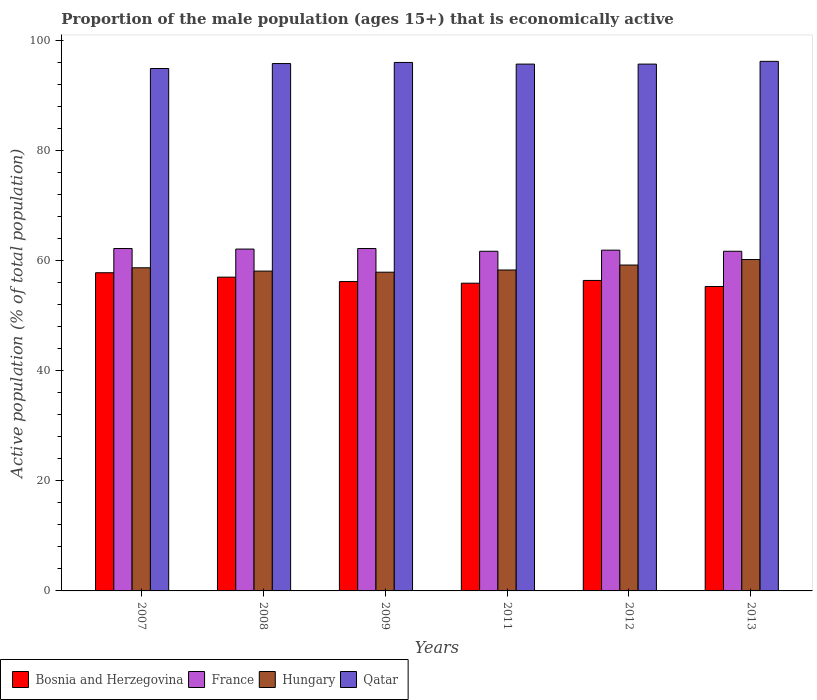How many different coloured bars are there?
Make the answer very short. 4. How many bars are there on the 4th tick from the right?
Give a very brief answer. 4. What is the label of the 5th group of bars from the left?
Your response must be concise. 2012. What is the proportion of the male population that is economically active in Hungary in 2008?
Your response must be concise. 58.1. Across all years, what is the maximum proportion of the male population that is economically active in France?
Keep it short and to the point. 62.2. Across all years, what is the minimum proportion of the male population that is economically active in Qatar?
Provide a short and direct response. 94.9. In which year was the proportion of the male population that is economically active in Bosnia and Herzegovina maximum?
Give a very brief answer. 2007. What is the total proportion of the male population that is economically active in Qatar in the graph?
Your response must be concise. 574.3. What is the difference between the proportion of the male population that is economically active in Hungary in 2009 and that in 2013?
Ensure brevity in your answer.  -2.3. What is the difference between the proportion of the male population that is economically active in Qatar in 2011 and the proportion of the male population that is economically active in Hungary in 2013?
Provide a succinct answer. 35.5. What is the average proportion of the male population that is economically active in Qatar per year?
Make the answer very short. 95.72. In the year 2011, what is the difference between the proportion of the male population that is economically active in Bosnia and Herzegovina and proportion of the male population that is economically active in France?
Your answer should be compact. -5.8. In how many years, is the proportion of the male population that is economically active in Hungary greater than 12 %?
Provide a succinct answer. 6. What is the ratio of the proportion of the male population that is economically active in Hungary in 2012 to that in 2013?
Give a very brief answer. 0.98. What is the difference between the highest and the second highest proportion of the male population that is economically active in Hungary?
Keep it short and to the point. 1. What is the difference between the highest and the lowest proportion of the male population that is economically active in France?
Ensure brevity in your answer.  0.5. In how many years, is the proportion of the male population that is economically active in Hungary greater than the average proportion of the male population that is economically active in Hungary taken over all years?
Provide a short and direct response. 2. What does the 3rd bar from the left in 2009 represents?
Keep it short and to the point. Hungary. What does the 4th bar from the right in 2009 represents?
Give a very brief answer. Bosnia and Herzegovina. Is it the case that in every year, the sum of the proportion of the male population that is economically active in Bosnia and Herzegovina and proportion of the male population that is economically active in France is greater than the proportion of the male population that is economically active in Hungary?
Your response must be concise. Yes. How many bars are there?
Ensure brevity in your answer.  24. Are all the bars in the graph horizontal?
Ensure brevity in your answer.  No. What is the difference between two consecutive major ticks on the Y-axis?
Offer a very short reply. 20. Does the graph contain any zero values?
Make the answer very short. No. Where does the legend appear in the graph?
Keep it short and to the point. Bottom left. How many legend labels are there?
Offer a very short reply. 4. How are the legend labels stacked?
Provide a short and direct response. Horizontal. What is the title of the graph?
Offer a very short reply. Proportion of the male population (ages 15+) that is economically active. Does "Mali" appear as one of the legend labels in the graph?
Your answer should be very brief. No. What is the label or title of the Y-axis?
Your response must be concise. Active population (% of total population). What is the Active population (% of total population) in Bosnia and Herzegovina in 2007?
Your answer should be compact. 57.8. What is the Active population (% of total population) in France in 2007?
Provide a succinct answer. 62.2. What is the Active population (% of total population) of Hungary in 2007?
Offer a terse response. 58.7. What is the Active population (% of total population) of Qatar in 2007?
Offer a very short reply. 94.9. What is the Active population (% of total population) of Bosnia and Herzegovina in 2008?
Your response must be concise. 57. What is the Active population (% of total population) in France in 2008?
Provide a succinct answer. 62.1. What is the Active population (% of total population) of Hungary in 2008?
Ensure brevity in your answer.  58.1. What is the Active population (% of total population) in Qatar in 2008?
Your answer should be compact. 95.8. What is the Active population (% of total population) of Bosnia and Herzegovina in 2009?
Give a very brief answer. 56.2. What is the Active population (% of total population) in France in 2009?
Your answer should be compact. 62.2. What is the Active population (% of total population) in Hungary in 2009?
Ensure brevity in your answer.  57.9. What is the Active population (% of total population) in Qatar in 2009?
Your answer should be very brief. 96. What is the Active population (% of total population) in Bosnia and Herzegovina in 2011?
Your answer should be compact. 55.9. What is the Active population (% of total population) in France in 2011?
Offer a very short reply. 61.7. What is the Active population (% of total population) of Hungary in 2011?
Give a very brief answer. 58.3. What is the Active population (% of total population) in Qatar in 2011?
Your response must be concise. 95.7. What is the Active population (% of total population) in Bosnia and Herzegovina in 2012?
Offer a terse response. 56.4. What is the Active population (% of total population) in France in 2012?
Give a very brief answer. 61.9. What is the Active population (% of total population) of Hungary in 2012?
Ensure brevity in your answer.  59.2. What is the Active population (% of total population) of Qatar in 2012?
Offer a terse response. 95.7. What is the Active population (% of total population) of Bosnia and Herzegovina in 2013?
Offer a terse response. 55.3. What is the Active population (% of total population) in France in 2013?
Give a very brief answer. 61.7. What is the Active population (% of total population) in Hungary in 2013?
Your answer should be very brief. 60.2. What is the Active population (% of total population) in Qatar in 2013?
Provide a short and direct response. 96.2. Across all years, what is the maximum Active population (% of total population) of Bosnia and Herzegovina?
Your answer should be compact. 57.8. Across all years, what is the maximum Active population (% of total population) of France?
Provide a succinct answer. 62.2. Across all years, what is the maximum Active population (% of total population) of Hungary?
Give a very brief answer. 60.2. Across all years, what is the maximum Active population (% of total population) of Qatar?
Provide a short and direct response. 96.2. Across all years, what is the minimum Active population (% of total population) of Bosnia and Herzegovina?
Offer a terse response. 55.3. Across all years, what is the minimum Active population (% of total population) in France?
Provide a short and direct response. 61.7. Across all years, what is the minimum Active population (% of total population) of Hungary?
Give a very brief answer. 57.9. Across all years, what is the minimum Active population (% of total population) in Qatar?
Your response must be concise. 94.9. What is the total Active population (% of total population) in Bosnia and Herzegovina in the graph?
Provide a short and direct response. 338.6. What is the total Active population (% of total population) of France in the graph?
Make the answer very short. 371.8. What is the total Active population (% of total population) in Hungary in the graph?
Provide a short and direct response. 352.4. What is the total Active population (% of total population) of Qatar in the graph?
Provide a succinct answer. 574.3. What is the difference between the Active population (% of total population) in France in 2007 and that in 2008?
Make the answer very short. 0.1. What is the difference between the Active population (% of total population) of Hungary in 2007 and that in 2008?
Offer a terse response. 0.6. What is the difference between the Active population (% of total population) of Qatar in 2007 and that in 2008?
Make the answer very short. -0.9. What is the difference between the Active population (% of total population) in Bosnia and Herzegovina in 2007 and that in 2009?
Ensure brevity in your answer.  1.6. What is the difference between the Active population (% of total population) of France in 2007 and that in 2009?
Offer a terse response. 0. What is the difference between the Active population (% of total population) of Hungary in 2007 and that in 2009?
Provide a succinct answer. 0.8. What is the difference between the Active population (% of total population) in Qatar in 2007 and that in 2009?
Your answer should be compact. -1.1. What is the difference between the Active population (% of total population) of Bosnia and Herzegovina in 2007 and that in 2011?
Offer a terse response. 1.9. What is the difference between the Active population (% of total population) of France in 2007 and that in 2011?
Your response must be concise. 0.5. What is the difference between the Active population (% of total population) in Hungary in 2007 and that in 2011?
Offer a terse response. 0.4. What is the difference between the Active population (% of total population) of Qatar in 2007 and that in 2011?
Give a very brief answer. -0.8. What is the difference between the Active population (% of total population) of Hungary in 2007 and that in 2012?
Offer a terse response. -0.5. What is the difference between the Active population (% of total population) of Hungary in 2007 and that in 2013?
Offer a very short reply. -1.5. What is the difference between the Active population (% of total population) in Hungary in 2008 and that in 2009?
Your answer should be compact. 0.2. What is the difference between the Active population (% of total population) in Qatar in 2008 and that in 2009?
Provide a succinct answer. -0.2. What is the difference between the Active population (% of total population) of Bosnia and Herzegovina in 2008 and that in 2011?
Your response must be concise. 1.1. What is the difference between the Active population (% of total population) of France in 2008 and that in 2011?
Your response must be concise. 0.4. What is the difference between the Active population (% of total population) in Bosnia and Herzegovina in 2008 and that in 2012?
Give a very brief answer. 0.6. What is the difference between the Active population (% of total population) of France in 2008 and that in 2012?
Your response must be concise. 0.2. What is the difference between the Active population (% of total population) of Qatar in 2008 and that in 2013?
Your response must be concise. -0.4. What is the difference between the Active population (% of total population) in France in 2009 and that in 2011?
Provide a succinct answer. 0.5. What is the difference between the Active population (% of total population) of Hungary in 2009 and that in 2011?
Offer a very short reply. -0.4. What is the difference between the Active population (% of total population) in France in 2009 and that in 2012?
Provide a succinct answer. 0.3. What is the difference between the Active population (% of total population) in Bosnia and Herzegovina in 2009 and that in 2013?
Offer a terse response. 0.9. What is the difference between the Active population (% of total population) in France in 2009 and that in 2013?
Keep it short and to the point. 0.5. What is the difference between the Active population (% of total population) of Bosnia and Herzegovina in 2011 and that in 2012?
Give a very brief answer. -0.5. What is the difference between the Active population (% of total population) in France in 2011 and that in 2012?
Keep it short and to the point. -0.2. What is the difference between the Active population (% of total population) in Hungary in 2011 and that in 2012?
Provide a succinct answer. -0.9. What is the difference between the Active population (% of total population) of France in 2011 and that in 2013?
Your answer should be compact. 0. What is the difference between the Active population (% of total population) of Qatar in 2011 and that in 2013?
Give a very brief answer. -0.5. What is the difference between the Active population (% of total population) of Bosnia and Herzegovina in 2007 and the Active population (% of total population) of Qatar in 2008?
Provide a short and direct response. -38. What is the difference between the Active population (% of total population) in France in 2007 and the Active population (% of total population) in Hungary in 2008?
Give a very brief answer. 4.1. What is the difference between the Active population (% of total population) in France in 2007 and the Active population (% of total population) in Qatar in 2008?
Make the answer very short. -33.6. What is the difference between the Active population (% of total population) in Hungary in 2007 and the Active population (% of total population) in Qatar in 2008?
Ensure brevity in your answer.  -37.1. What is the difference between the Active population (% of total population) of Bosnia and Herzegovina in 2007 and the Active population (% of total population) of France in 2009?
Offer a terse response. -4.4. What is the difference between the Active population (% of total population) of Bosnia and Herzegovina in 2007 and the Active population (% of total population) of Hungary in 2009?
Your response must be concise. -0.1. What is the difference between the Active population (% of total population) in Bosnia and Herzegovina in 2007 and the Active population (% of total population) in Qatar in 2009?
Ensure brevity in your answer.  -38.2. What is the difference between the Active population (% of total population) of France in 2007 and the Active population (% of total population) of Qatar in 2009?
Provide a short and direct response. -33.8. What is the difference between the Active population (% of total population) of Hungary in 2007 and the Active population (% of total population) of Qatar in 2009?
Your response must be concise. -37.3. What is the difference between the Active population (% of total population) of Bosnia and Herzegovina in 2007 and the Active population (% of total population) of Qatar in 2011?
Keep it short and to the point. -37.9. What is the difference between the Active population (% of total population) in France in 2007 and the Active population (% of total population) in Qatar in 2011?
Offer a terse response. -33.5. What is the difference between the Active population (% of total population) in Hungary in 2007 and the Active population (% of total population) in Qatar in 2011?
Provide a short and direct response. -37. What is the difference between the Active population (% of total population) of Bosnia and Herzegovina in 2007 and the Active population (% of total population) of France in 2012?
Give a very brief answer. -4.1. What is the difference between the Active population (% of total population) in Bosnia and Herzegovina in 2007 and the Active population (% of total population) in Qatar in 2012?
Your response must be concise. -37.9. What is the difference between the Active population (% of total population) in France in 2007 and the Active population (% of total population) in Qatar in 2012?
Ensure brevity in your answer.  -33.5. What is the difference between the Active population (% of total population) of Hungary in 2007 and the Active population (% of total population) of Qatar in 2012?
Provide a short and direct response. -37. What is the difference between the Active population (% of total population) in Bosnia and Herzegovina in 2007 and the Active population (% of total population) in Hungary in 2013?
Your response must be concise. -2.4. What is the difference between the Active population (% of total population) in Bosnia and Herzegovina in 2007 and the Active population (% of total population) in Qatar in 2013?
Keep it short and to the point. -38.4. What is the difference between the Active population (% of total population) of France in 2007 and the Active population (% of total population) of Qatar in 2013?
Your answer should be compact. -34. What is the difference between the Active population (% of total population) of Hungary in 2007 and the Active population (% of total population) of Qatar in 2013?
Ensure brevity in your answer.  -37.5. What is the difference between the Active population (% of total population) in Bosnia and Herzegovina in 2008 and the Active population (% of total population) in Qatar in 2009?
Your answer should be very brief. -39. What is the difference between the Active population (% of total population) of France in 2008 and the Active population (% of total population) of Qatar in 2009?
Ensure brevity in your answer.  -33.9. What is the difference between the Active population (% of total population) in Hungary in 2008 and the Active population (% of total population) in Qatar in 2009?
Keep it short and to the point. -37.9. What is the difference between the Active population (% of total population) of Bosnia and Herzegovina in 2008 and the Active population (% of total population) of Qatar in 2011?
Your answer should be compact. -38.7. What is the difference between the Active population (% of total population) of France in 2008 and the Active population (% of total population) of Qatar in 2011?
Keep it short and to the point. -33.6. What is the difference between the Active population (% of total population) in Hungary in 2008 and the Active population (% of total population) in Qatar in 2011?
Offer a terse response. -37.6. What is the difference between the Active population (% of total population) in Bosnia and Herzegovina in 2008 and the Active population (% of total population) in France in 2012?
Offer a terse response. -4.9. What is the difference between the Active population (% of total population) in Bosnia and Herzegovina in 2008 and the Active population (% of total population) in Hungary in 2012?
Your response must be concise. -2.2. What is the difference between the Active population (% of total population) in Bosnia and Herzegovina in 2008 and the Active population (% of total population) in Qatar in 2012?
Your answer should be compact. -38.7. What is the difference between the Active population (% of total population) of France in 2008 and the Active population (% of total population) of Qatar in 2012?
Keep it short and to the point. -33.6. What is the difference between the Active population (% of total population) of Hungary in 2008 and the Active population (% of total population) of Qatar in 2012?
Keep it short and to the point. -37.6. What is the difference between the Active population (% of total population) in Bosnia and Herzegovina in 2008 and the Active population (% of total population) in Qatar in 2013?
Ensure brevity in your answer.  -39.2. What is the difference between the Active population (% of total population) of France in 2008 and the Active population (% of total population) of Qatar in 2013?
Your response must be concise. -34.1. What is the difference between the Active population (% of total population) in Hungary in 2008 and the Active population (% of total population) in Qatar in 2013?
Provide a short and direct response. -38.1. What is the difference between the Active population (% of total population) in Bosnia and Herzegovina in 2009 and the Active population (% of total population) in Hungary in 2011?
Keep it short and to the point. -2.1. What is the difference between the Active population (% of total population) of Bosnia and Herzegovina in 2009 and the Active population (% of total population) of Qatar in 2011?
Offer a terse response. -39.5. What is the difference between the Active population (% of total population) in France in 2009 and the Active population (% of total population) in Qatar in 2011?
Your answer should be very brief. -33.5. What is the difference between the Active population (% of total population) of Hungary in 2009 and the Active population (% of total population) of Qatar in 2011?
Your response must be concise. -37.8. What is the difference between the Active population (% of total population) of Bosnia and Herzegovina in 2009 and the Active population (% of total population) of France in 2012?
Make the answer very short. -5.7. What is the difference between the Active population (% of total population) of Bosnia and Herzegovina in 2009 and the Active population (% of total population) of Qatar in 2012?
Provide a short and direct response. -39.5. What is the difference between the Active population (% of total population) in France in 2009 and the Active population (% of total population) in Qatar in 2012?
Your answer should be compact. -33.5. What is the difference between the Active population (% of total population) of Hungary in 2009 and the Active population (% of total population) of Qatar in 2012?
Ensure brevity in your answer.  -37.8. What is the difference between the Active population (% of total population) of Bosnia and Herzegovina in 2009 and the Active population (% of total population) of France in 2013?
Your response must be concise. -5.5. What is the difference between the Active population (% of total population) of Bosnia and Herzegovina in 2009 and the Active population (% of total population) of Hungary in 2013?
Your answer should be compact. -4. What is the difference between the Active population (% of total population) of Bosnia and Herzegovina in 2009 and the Active population (% of total population) of Qatar in 2013?
Ensure brevity in your answer.  -40. What is the difference between the Active population (% of total population) of France in 2009 and the Active population (% of total population) of Qatar in 2013?
Your answer should be compact. -34. What is the difference between the Active population (% of total population) of Hungary in 2009 and the Active population (% of total population) of Qatar in 2013?
Your answer should be compact. -38.3. What is the difference between the Active population (% of total population) in Bosnia and Herzegovina in 2011 and the Active population (% of total population) in Hungary in 2012?
Ensure brevity in your answer.  -3.3. What is the difference between the Active population (% of total population) in Bosnia and Herzegovina in 2011 and the Active population (% of total population) in Qatar in 2012?
Give a very brief answer. -39.8. What is the difference between the Active population (% of total population) in France in 2011 and the Active population (% of total population) in Qatar in 2012?
Give a very brief answer. -34. What is the difference between the Active population (% of total population) in Hungary in 2011 and the Active population (% of total population) in Qatar in 2012?
Keep it short and to the point. -37.4. What is the difference between the Active population (% of total population) in Bosnia and Herzegovina in 2011 and the Active population (% of total population) in France in 2013?
Your answer should be very brief. -5.8. What is the difference between the Active population (% of total population) of Bosnia and Herzegovina in 2011 and the Active population (% of total population) of Qatar in 2013?
Give a very brief answer. -40.3. What is the difference between the Active population (% of total population) in France in 2011 and the Active population (% of total population) in Qatar in 2013?
Provide a short and direct response. -34.5. What is the difference between the Active population (% of total population) of Hungary in 2011 and the Active population (% of total population) of Qatar in 2013?
Your answer should be very brief. -37.9. What is the difference between the Active population (% of total population) of Bosnia and Herzegovina in 2012 and the Active population (% of total population) of Qatar in 2013?
Your response must be concise. -39.8. What is the difference between the Active population (% of total population) in France in 2012 and the Active population (% of total population) in Hungary in 2013?
Offer a very short reply. 1.7. What is the difference between the Active population (% of total population) of France in 2012 and the Active population (% of total population) of Qatar in 2013?
Provide a succinct answer. -34.3. What is the difference between the Active population (% of total population) of Hungary in 2012 and the Active population (% of total population) of Qatar in 2013?
Your answer should be very brief. -37. What is the average Active population (% of total population) in Bosnia and Herzegovina per year?
Ensure brevity in your answer.  56.43. What is the average Active population (% of total population) of France per year?
Ensure brevity in your answer.  61.97. What is the average Active population (% of total population) in Hungary per year?
Your answer should be compact. 58.73. What is the average Active population (% of total population) of Qatar per year?
Offer a terse response. 95.72. In the year 2007, what is the difference between the Active population (% of total population) of Bosnia and Herzegovina and Active population (% of total population) of Qatar?
Your answer should be very brief. -37.1. In the year 2007, what is the difference between the Active population (% of total population) in France and Active population (% of total population) in Qatar?
Keep it short and to the point. -32.7. In the year 2007, what is the difference between the Active population (% of total population) in Hungary and Active population (% of total population) in Qatar?
Offer a terse response. -36.2. In the year 2008, what is the difference between the Active population (% of total population) in Bosnia and Herzegovina and Active population (% of total population) in France?
Ensure brevity in your answer.  -5.1. In the year 2008, what is the difference between the Active population (% of total population) of Bosnia and Herzegovina and Active population (% of total population) of Qatar?
Offer a very short reply. -38.8. In the year 2008, what is the difference between the Active population (% of total population) in France and Active population (% of total population) in Hungary?
Ensure brevity in your answer.  4. In the year 2008, what is the difference between the Active population (% of total population) of France and Active population (% of total population) of Qatar?
Ensure brevity in your answer.  -33.7. In the year 2008, what is the difference between the Active population (% of total population) of Hungary and Active population (% of total population) of Qatar?
Offer a very short reply. -37.7. In the year 2009, what is the difference between the Active population (% of total population) of Bosnia and Herzegovina and Active population (% of total population) of Hungary?
Provide a short and direct response. -1.7. In the year 2009, what is the difference between the Active population (% of total population) in Bosnia and Herzegovina and Active population (% of total population) in Qatar?
Offer a very short reply. -39.8. In the year 2009, what is the difference between the Active population (% of total population) in France and Active population (% of total population) in Qatar?
Your answer should be compact. -33.8. In the year 2009, what is the difference between the Active population (% of total population) in Hungary and Active population (% of total population) in Qatar?
Give a very brief answer. -38.1. In the year 2011, what is the difference between the Active population (% of total population) of Bosnia and Herzegovina and Active population (% of total population) of Qatar?
Make the answer very short. -39.8. In the year 2011, what is the difference between the Active population (% of total population) of France and Active population (% of total population) of Hungary?
Your answer should be compact. 3.4. In the year 2011, what is the difference between the Active population (% of total population) of France and Active population (% of total population) of Qatar?
Offer a very short reply. -34. In the year 2011, what is the difference between the Active population (% of total population) in Hungary and Active population (% of total population) in Qatar?
Your response must be concise. -37.4. In the year 2012, what is the difference between the Active population (% of total population) in Bosnia and Herzegovina and Active population (% of total population) in France?
Offer a terse response. -5.5. In the year 2012, what is the difference between the Active population (% of total population) of Bosnia and Herzegovina and Active population (% of total population) of Qatar?
Your response must be concise. -39.3. In the year 2012, what is the difference between the Active population (% of total population) in France and Active population (% of total population) in Qatar?
Your answer should be compact. -33.8. In the year 2012, what is the difference between the Active population (% of total population) of Hungary and Active population (% of total population) of Qatar?
Ensure brevity in your answer.  -36.5. In the year 2013, what is the difference between the Active population (% of total population) of Bosnia and Herzegovina and Active population (% of total population) of Hungary?
Provide a succinct answer. -4.9. In the year 2013, what is the difference between the Active population (% of total population) in Bosnia and Herzegovina and Active population (% of total population) in Qatar?
Your answer should be compact. -40.9. In the year 2013, what is the difference between the Active population (% of total population) in France and Active population (% of total population) in Hungary?
Your response must be concise. 1.5. In the year 2013, what is the difference between the Active population (% of total population) of France and Active population (% of total population) of Qatar?
Your answer should be compact. -34.5. In the year 2013, what is the difference between the Active population (% of total population) in Hungary and Active population (% of total population) in Qatar?
Your answer should be very brief. -36. What is the ratio of the Active population (% of total population) of Bosnia and Herzegovina in 2007 to that in 2008?
Your answer should be very brief. 1.01. What is the ratio of the Active population (% of total population) in Hungary in 2007 to that in 2008?
Your answer should be very brief. 1.01. What is the ratio of the Active population (% of total population) in Qatar in 2007 to that in 2008?
Offer a terse response. 0.99. What is the ratio of the Active population (% of total population) in Bosnia and Herzegovina in 2007 to that in 2009?
Ensure brevity in your answer.  1.03. What is the ratio of the Active population (% of total population) of France in 2007 to that in 2009?
Offer a very short reply. 1. What is the ratio of the Active population (% of total population) of Hungary in 2007 to that in 2009?
Give a very brief answer. 1.01. What is the ratio of the Active population (% of total population) in Qatar in 2007 to that in 2009?
Provide a short and direct response. 0.99. What is the ratio of the Active population (% of total population) of Bosnia and Herzegovina in 2007 to that in 2011?
Offer a very short reply. 1.03. What is the ratio of the Active population (% of total population) of France in 2007 to that in 2011?
Offer a very short reply. 1.01. What is the ratio of the Active population (% of total population) in Hungary in 2007 to that in 2011?
Offer a terse response. 1.01. What is the ratio of the Active population (% of total population) in Bosnia and Herzegovina in 2007 to that in 2012?
Provide a short and direct response. 1.02. What is the ratio of the Active population (% of total population) of Qatar in 2007 to that in 2012?
Your response must be concise. 0.99. What is the ratio of the Active population (% of total population) in Bosnia and Herzegovina in 2007 to that in 2013?
Keep it short and to the point. 1.05. What is the ratio of the Active population (% of total population) in Hungary in 2007 to that in 2013?
Make the answer very short. 0.98. What is the ratio of the Active population (% of total population) in Qatar in 2007 to that in 2013?
Give a very brief answer. 0.99. What is the ratio of the Active population (% of total population) in Bosnia and Herzegovina in 2008 to that in 2009?
Keep it short and to the point. 1.01. What is the ratio of the Active population (% of total population) in Bosnia and Herzegovina in 2008 to that in 2011?
Offer a terse response. 1.02. What is the ratio of the Active population (% of total population) in Qatar in 2008 to that in 2011?
Provide a short and direct response. 1. What is the ratio of the Active population (% of total population) in Bosnia and Herzegovina in 2008 to that in 2012?
Make the answer very short. 1.01. What is the ratio of the Active population (% of total population) in France in 2008 to that in 2012?
Provide a succinct answer. 1. What is the ratio of the Active population (% of total population) of Hungary in 2008 to that in 2012?
Give a very brief answer. 0.98. What is the ratio of the Active population (% of total population) in Bosnia and Herzegovina in 2008 to that in 2013?
Your response must be concise. 1.03. What is the ratio of the Active population (% of total population) of Hungary in 2008 to that in 2013?
Provide a succinct answer. 0.97. What is the ratio of the Active population (% of total population) of Qatar in 2008 to that in 2013?
Provide a succinct answer. 1. What is the ratio of the Active population (% of total population) in Bosnia and Herzegovina in 2009 to that in 2011?
Give a very brief answer. 1.01. What is the ratio of the Active population (% of total population) of France in 2009 to that in 2011?
Your response must be concise. 1.01. What is the ratio of the Active population (% of total population) of Bosnia and Herzegovina in 2009 to that in 2012?
Your response must be concise. 1. What is the ratio of the Active population (% of total population) in France in 2009 to that in 2012?
Provide a short and direct response. 1. What is the ratio of the Active population (% of total population) in Hungary in 2009 to that in 2012?
Your answer should be compact. 0.98. What is the ratio of the Active population (% of total population) of Bosnia and Herzegovina in 2009 to that in 2013?
Ensure brevity in your answer.  1.02. What is the ratio of the Active population (% of total population) of Hungary in 2009 to that in 2013?
Keep it short and to the point. 0.96. What is the ratio of the Active population (% of total population) of Qatar in 2009 to that in 2013?
Your answer should be compact. 1. What is the ratio of the Active population (% of total population) of Hungary in 2011 to that in 2012?
Offer a terse response. 0.98. What is the ratio of the Active population (% of total population) of Qatar in 2011 to that in 2012?
Your response must be concise. 1. What is the ratio of the Active population (% of total population) of Bosnia and Herzegovina in 2011 to that in 2013?
Your answer should be very brief. 1.01. What is the ratio of the Active population (% of total population) of France in 2011 to that in 2013?
Ensure brevity in your answer.  1. What is the ratio of the Active population (% of total population) in Hungary in 2011 to that in 2013?
Offer a very short reply. 0.97. What is the ratio of the Active population (% of total population) in Bosnia and Herzegovina in 2012 to that in 2013?
Ensure brevity in your answer.  1.02. What is the ratio of the Active population (% of total population) of Hungary in 2012 to that in 2013?
Offer a very short reply. 0.98. What is the ratio of the Active population (% of total population) of Qatar in 2012 to that in 2013?
Your answer should be compact. 0.99. What is the difference between the highest and the second highest Active population (% of total population) in Bosnia and Herzegovina?
Your answer should be very brief. 0.8. What is the difference between the highest and the second highest Active population (% of total population) in Hungary?
Your response must be concise. 1. What is the difference between the highest and the lowest Active population (% of total population) in Hungary?
Make the answer very short. 2.3. 